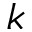<formula> <loc_0><loc_0><loc_500><loc_500>k</formula> 